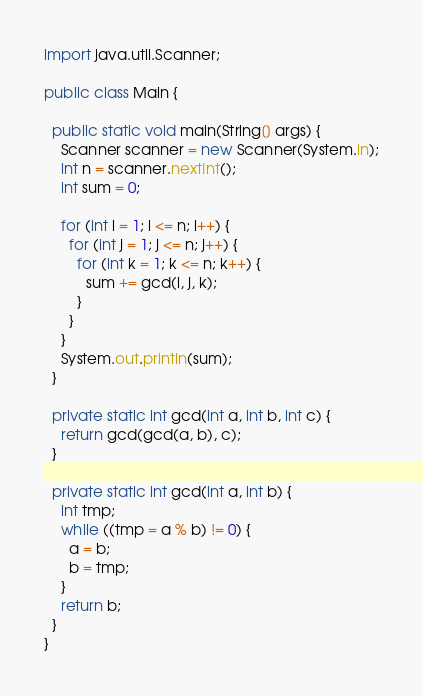<code> <loc_0><loc_0><loc_500><loc_500><_Java_>
import java.util.Scanner;

public class Main {

  public static void main(String[] args) {
    Scanner scanner = new Scanner(System.in);
    int n = scanner.nextInt();
    int sum = 0;

    for (int i = 1; i <= n; i++) {
      for (int j = 1; j <= n; j++) {
        for (int k = 1; k <= n; k++) {
          sum += gcd(i, j, k);
        }
      }
    }
    System.out.println(sum);
  }

  private static int gcd(int a, int b, int c) {
    return gcd(gcd(a, b), c);
  }

  private static int gcd(int a, int b) {
    int tmp;
    while ((tmp = a % b) != 0) {
      a = b;
      b = tmp;
    }
    return b;
  }
}
</code> 